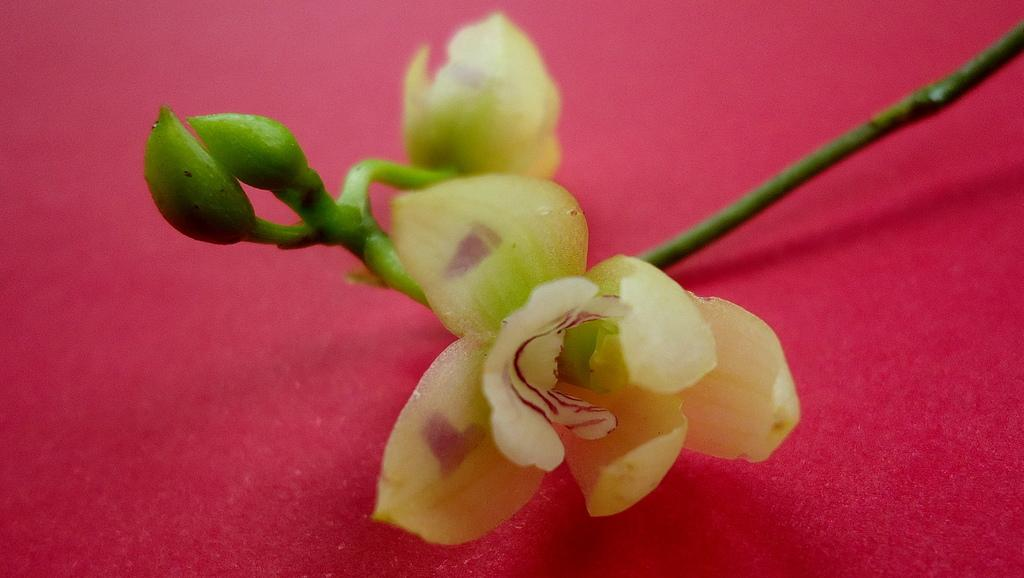What type of plants can be seen in the image? There are flowers in the image. Can you describe the stage of growth for some of the plants? Yes, there are buds in the image. What color is the surface in the image? The surface is red. What country is depicted in the image? There is no country depicted in the image; it features flowers and buds on a red surface. How many kittens can be seen sleeping in the image? There are no kittens present in the image. 